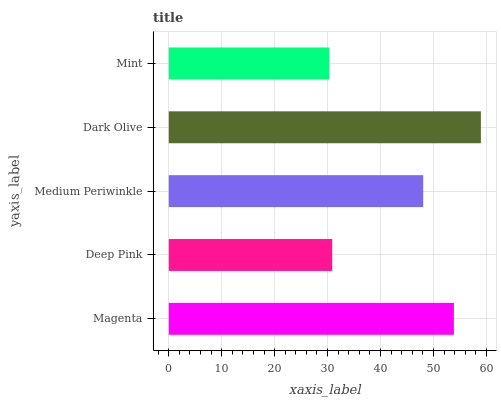Is Mint the minimum?
Answer yes or no. Yes. Is Dark Olive the maximum?
Answer yes or no. Yes. Is Deep Pink the minimum?
Answer yes or no. No. Is Deep Pink the maximum?
Answer yes or no. No. Is Magenta greater than Deep Pink?
Answer yes or no. Yes. Is Deep Pink less than Magenta?
Answer yes or no. Yes. Is Deep Pink greater than Magenta?
Answer yes or no. No. Is Magenta less than Deep Pink?
Answer yes or no. No. Is Medium Periwinkle the high median?
Answer yes or no. Yes. Is Medium Periwinkle the low median?
Answer yes or no. Yes. Is Magenta the high median?
Answer yes or no. No. Is Deep Pink the low median?
Answer yes or no. No. 